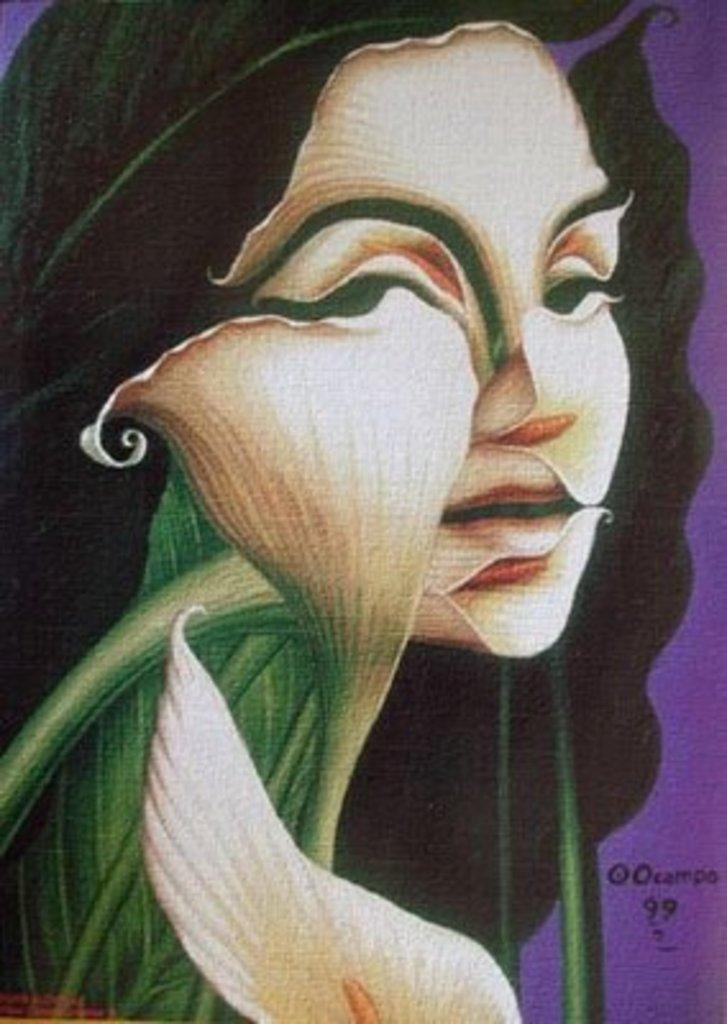What is the main subject of the painting in the image? The painting depicts a woman's face. Are there any additional elements in the painting besides the woman's face? Yes, the painting includes a flower and text. What type of collar can be seen on the woman in the painting? There is no collar visible on the woman in the painting; it only depicts her face. 